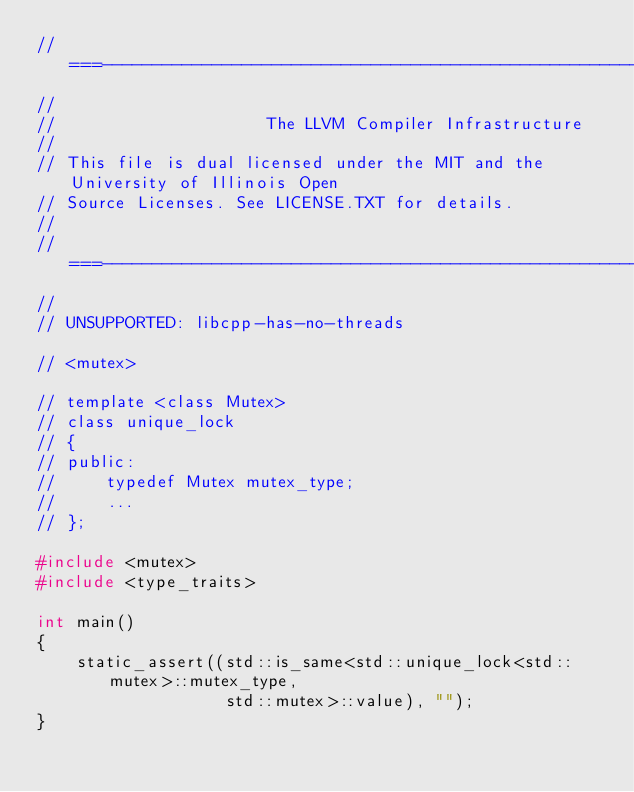<code> <loc_0><loc_0><loc_500><loc_500><_C++_>//===----------------------------------------------------------------------===//
//
//                     The LLVM Compiler Infrastructure
//
// This file is dual licensed under the MIT and the University of Illinois Open
// Source Licenses. See LICENSE.TXT for details.
//
//===----------------------------------------------------------------------===//
//
// UNSUPPORTED: libcpp-has-no-threads

// <mutex>

// template <class Mutex>
// class unique_lock
// {
// public:
//     typedef Mutex mutex_type;
//     ...
// };

#include <mutex>
#include <type_traits>

int main()
{
    static_assert((std::is_same<std::unique_lock<std::mutex>::mutex_type,
                   std::mutex>::value), "");
}
</code> 